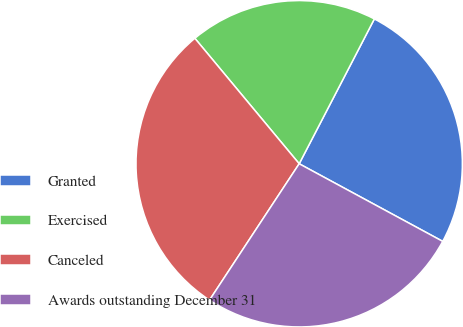<chart> <loc_0><loc_0><loc_500><loc_500><pie_chart><fcel>Granted<fcel>Exercised<fcel>Canceled<fcel>Awards outstanding December 31<nl><fcel>25.27%<fcel>18.66%<fcel>29.7%<fcel>26.37%<nl></chart> 